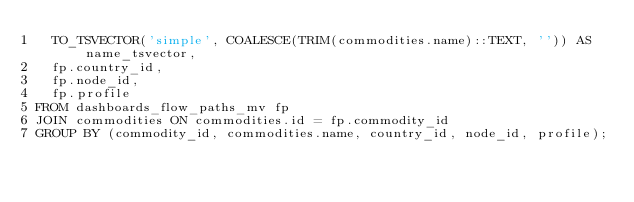Convert code to text. <code><loc_0><loc_0><loc_500><loc_500><_SQL_>  TO_TSVECTOR('simple', COALESCE(TRIM(commodities.name)::TEXT, '')) AS name_tsvector,
  fp.country_id,
  fp.node_id,
  fp.profile
FROM dashboards_flow_paths_mv fp
JOIN commodities ON commodities.id = fp.commodity_id
GROUP BY (commodity_id, commodities.name, country_id, node_id, profile);
</code> 